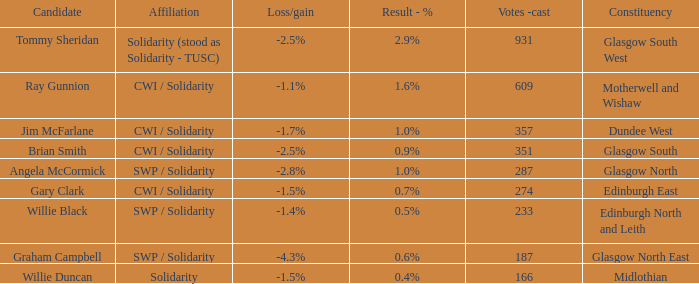How many votes were cast when the constituency was midlothian? 166.0. 